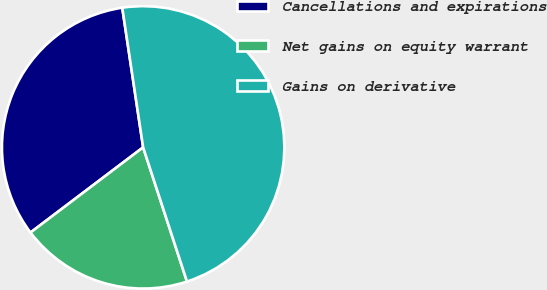Convert chart. <chart><loc_0><loc_0><loc_500><loc_500><pie_chart><fcel>Cancellations and expirations<fcel>Net gains on equity warrant<fcel>Gains on derivative<nl><fcel>32.94%<fcel>19.72%<fcel>47.33%<nl></chart> 